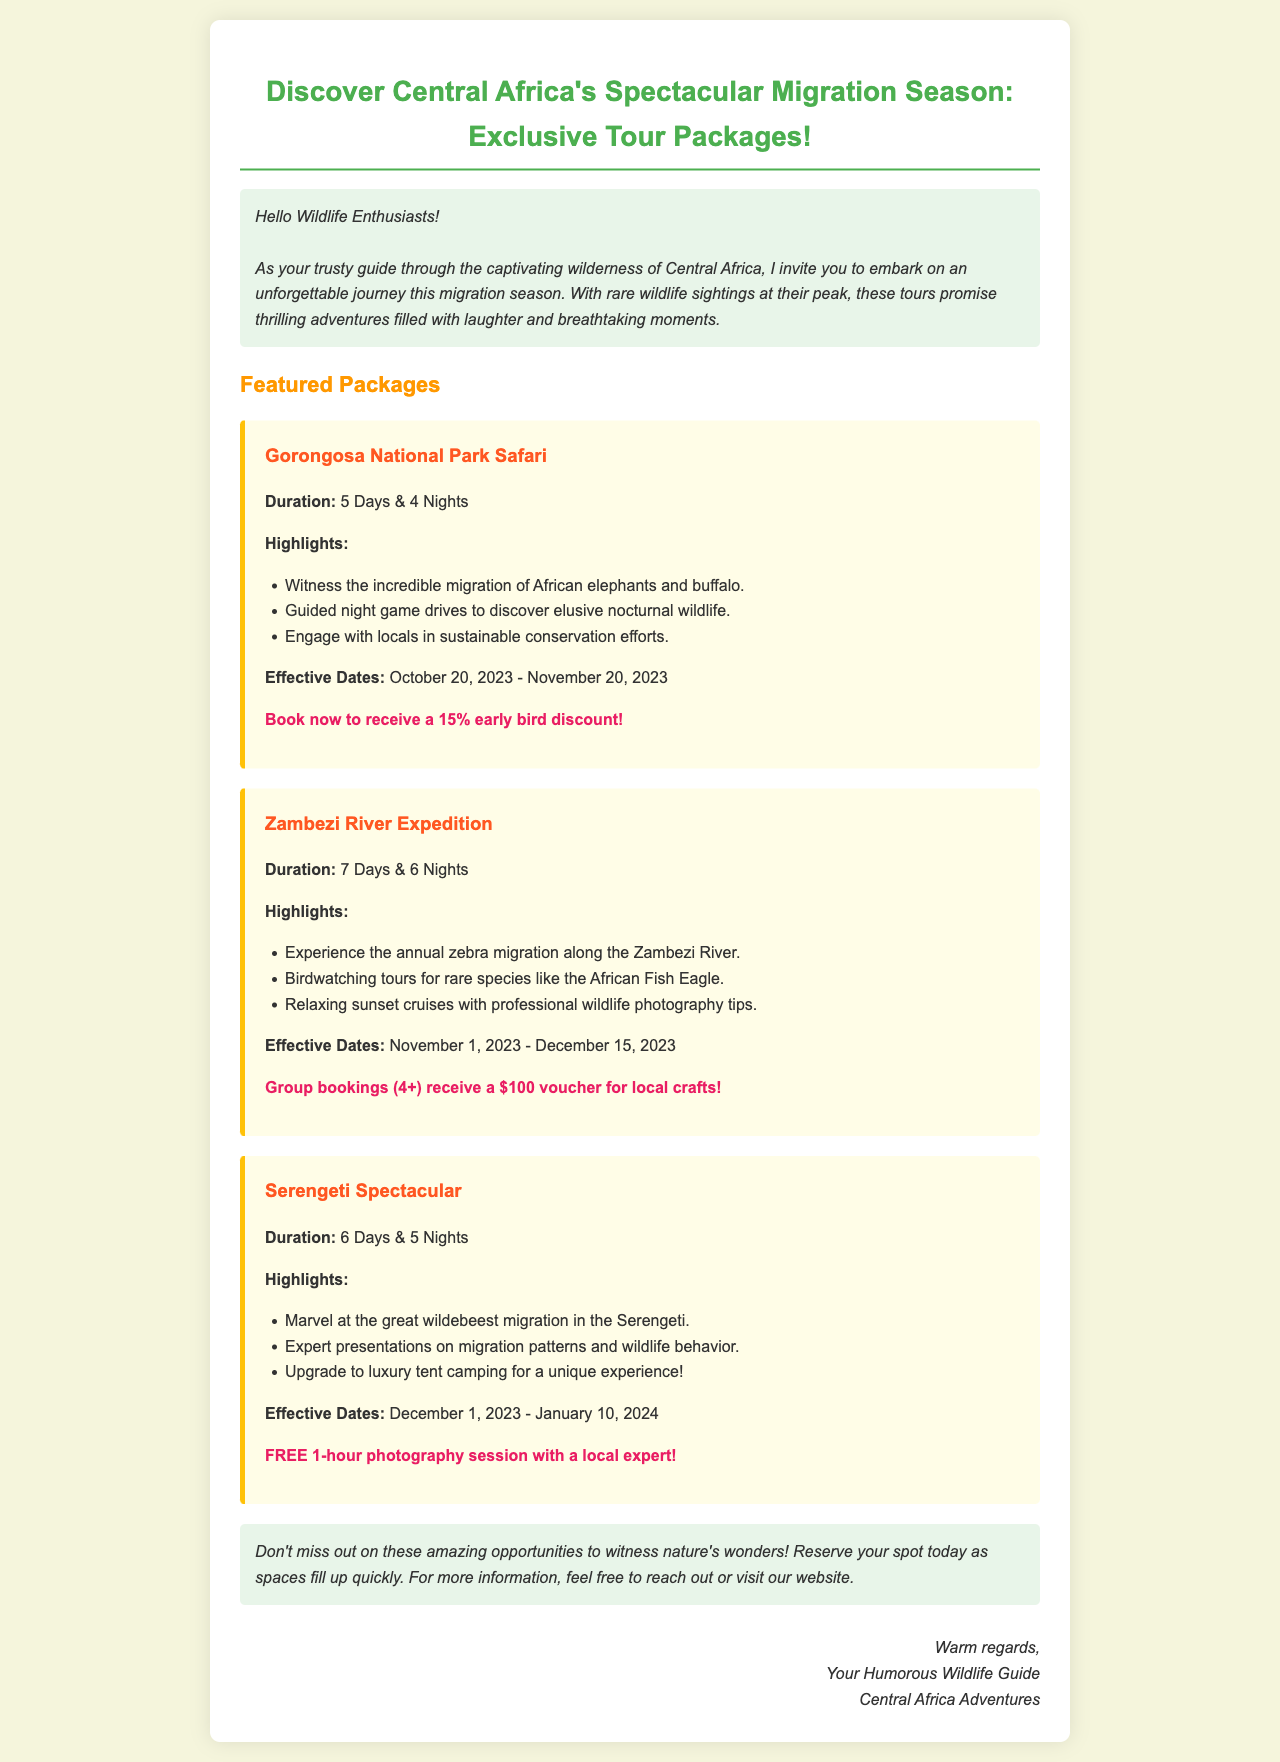what is the duration of the Gorongosa National Park Safari? The duration mentioned in the document is 5 Days & 4 Nights.
Answer: 5 Days & 4 Nights what is the early bird discount for the Gorongosa National Park Safari? The document states a 15% early bird discount for early bookings.
Answer: 15% what is the effective date range for the Zambezi River Expedition? The effective dates for this package are listed in the document as November 1, 2023 - December 15, 2023.
Answer: November 1, 2023 - December 15, 2023 how many nights do you spend on the Serengeti Spectacular tour? The document outlines that this tour lasts for 5 Nights.
Answer: 5 Nights what wildlife can you witness during the Gorongosa National Park Safari? The highlights state witnessing the migration of African elephants and buffalo during the safari.
Answer: African elephants and buffalo what is offered for group bookings of 4 or more on the Zambezi River Expedition? The document mentions a $100 voucher for local crafts for group bookings of 4 or more.
Answer: $100 voucher which package includes sunset cruises? The Zambezi River Expedition package highlights relaxing sunset cruises.
Answer: Zambezi River Expedition when does the Serengeti Spectacular tour start? The starting date for this tour is December 1, 2023, as mentioned in the document.
Answer: December 1, 2023 